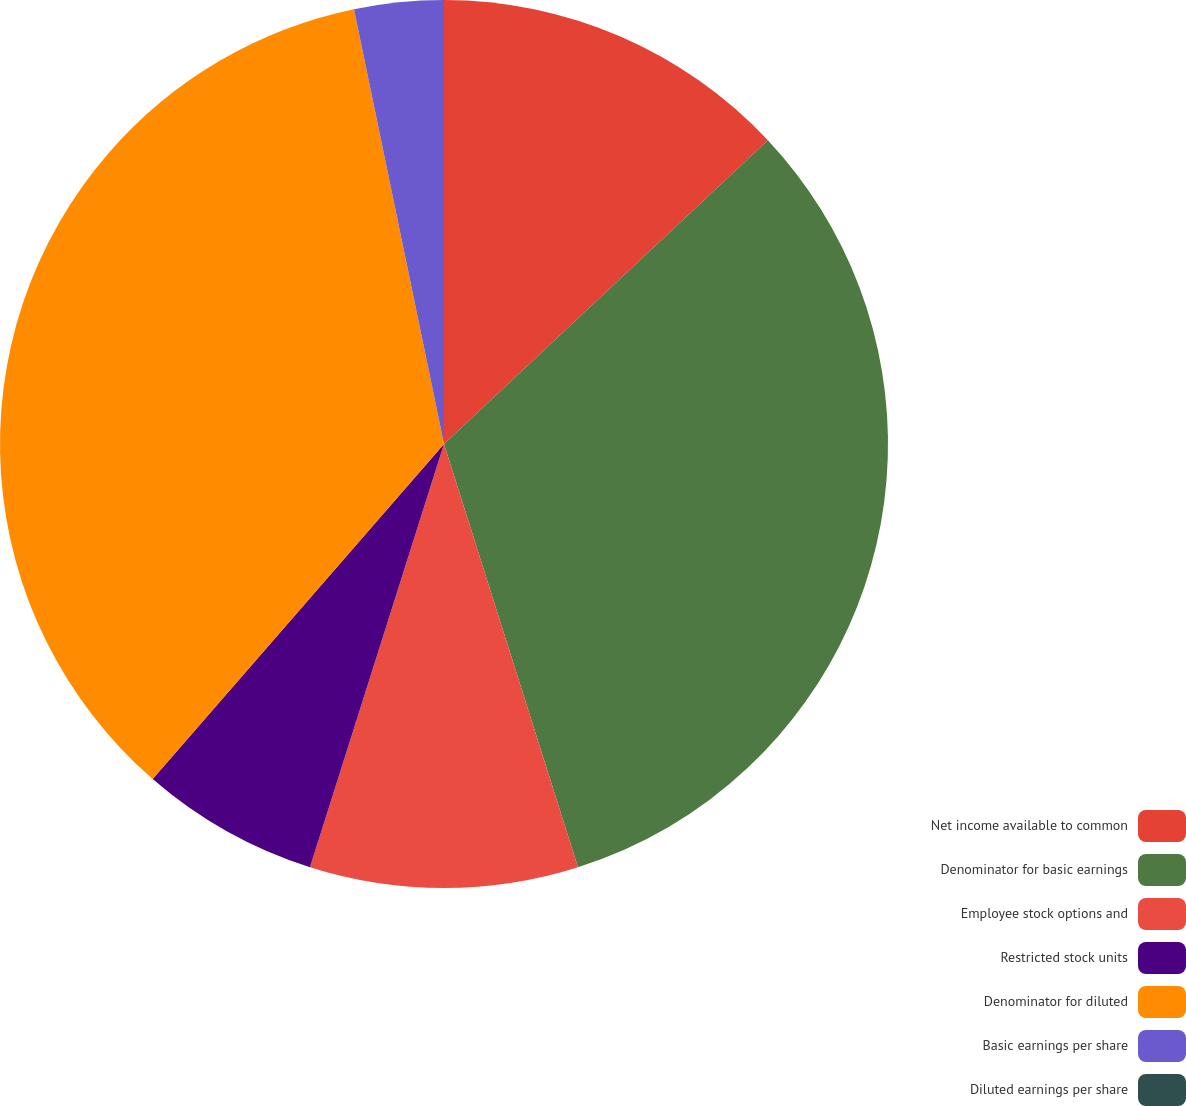Convert chart. <chart><loc_0><loc_0><loc_500><loc_500><pie_chart><fcel>Net income available to common<fcel>Denominator for basic earnings<fcel>Employee stock options and<fcel>Restricted stock units<fcel>Denominator for diluted<fcel>Basic earnings per share<fcel>Diluted earnings per share<nl><fcel>13.01%<fcel>32.11%<fcel>9.76%<fcel>6.51%<fcel>35.36%<fcel>3.25%<fcel>0.0%<nl></chart> 